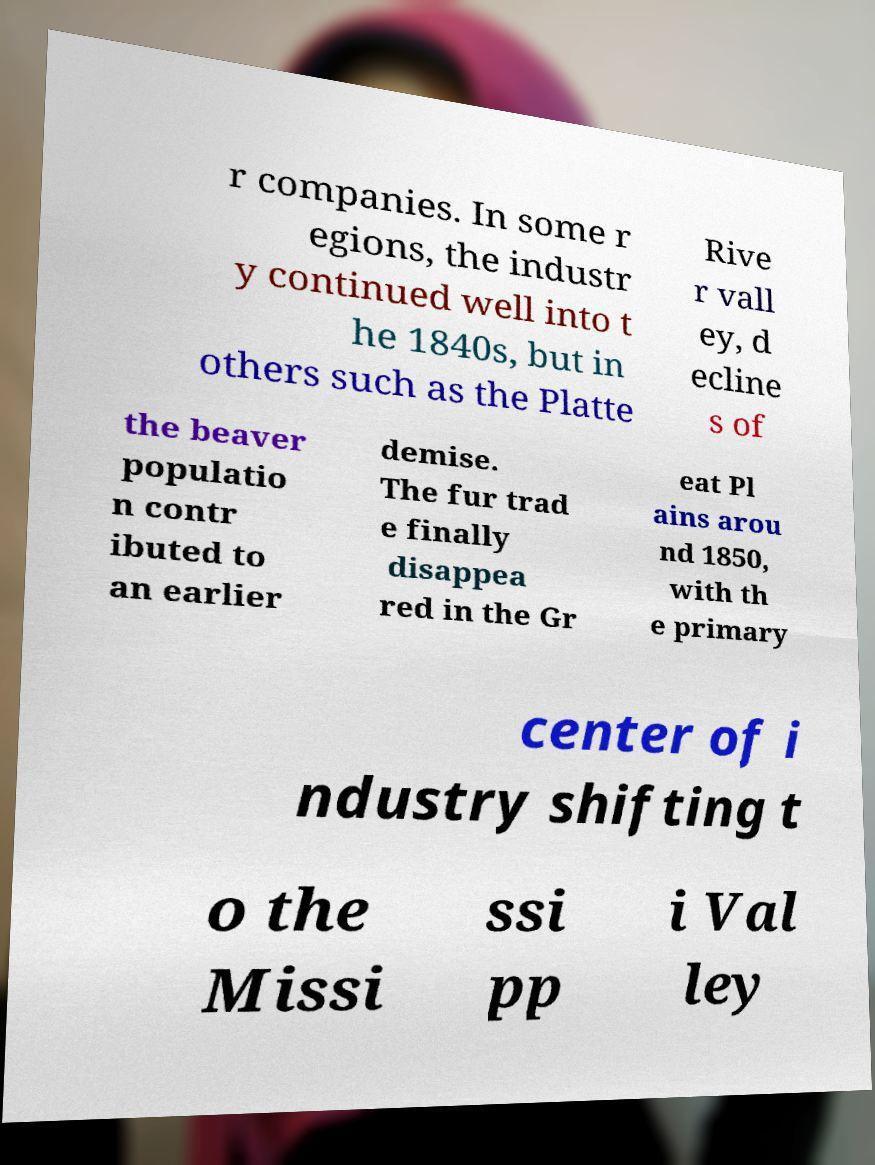Please read and relay the text visible in this image. What does it say? r companies. In some r egions, the industr y continued well into t he 1840s, but in others such as the Platte Rive r vall ey, d ecline s of the beaver populatio n contr ibuted to an earlier demise. The fur trad e finally disappea red in the Gr eat Pl ains arou nd 1850, with th e primary center of i ndustry shifting t o the Missi ssi pp i Val ley 